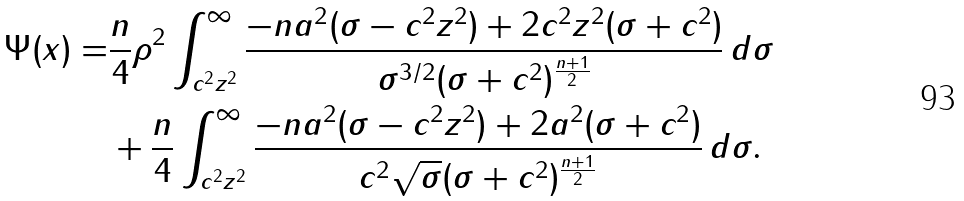<formula> <loc_0><loc_0><loc_500><loc_500>\Psi ( x ) = & \frac { n } { 4 } \rho ^ { 2 } \int _ { c ^ { 2 } z ^ { 2 } } ^ { \infty } \frac { - n a ^ { 2 } ( \sigma - c ^ { 2 } z ^ { 2 } ) + 2 c ^ { 2 } z ^ { 2 } ( \sigma + c ^ { 2 } ) } { \sigma ^ { 3 / 2 } ( \sigma + c ^ { 2 } ) ^ { \frac { n + 1 } 2 } } \, d \sigma \\ & + \frac { n } { 4 } \int _ { c ^ { 2 } z ^ { 2 } } ^ { \infty } \frac { - n a ^ { 2 } ( \sigma - c ^ { 2 } z ^ { 2 } ) + 2 a ^ { 2 } ( \sigma + c ^ { 2 } ) } { c ^ { 2 } \sqrt { \sigma } ( \sigma + c ^ { 2 } ) ^ { \frac { n + 1 } 2 } } \, d \sigma .</formula> 